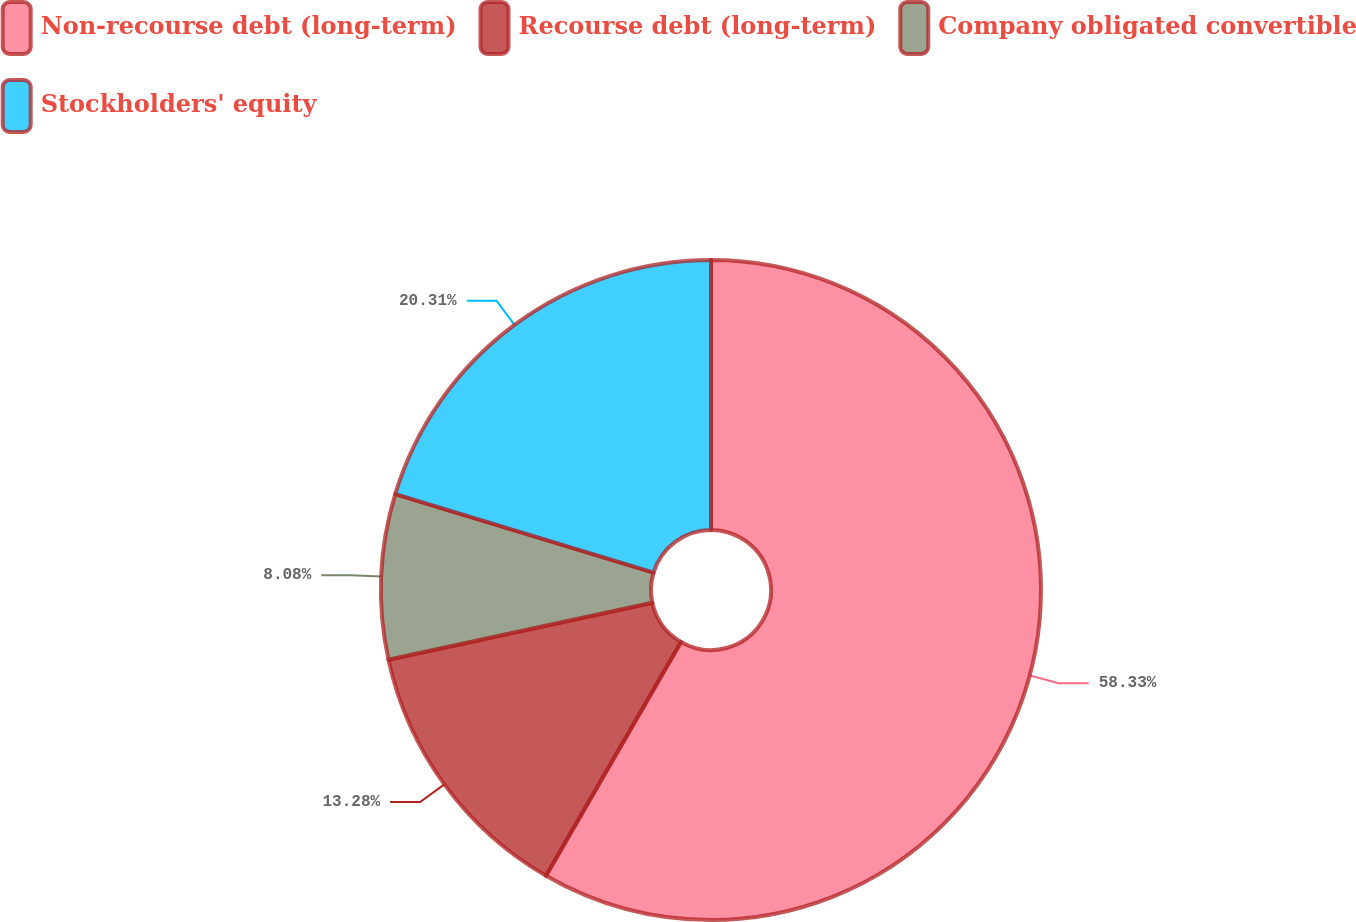<chart> <loc_0><loc_0><loc_500><loc_500><pie_chart><fcel>Non-recourse debt (long-term)<fcel>Recourse debt (long-term)<fcel>Company obligated convertible<fcel>Stockholders' equity<nl><fcel>58.34%<fcel>13.28%<fcel>8.08%<fcel>20.31%<nl></chart> 